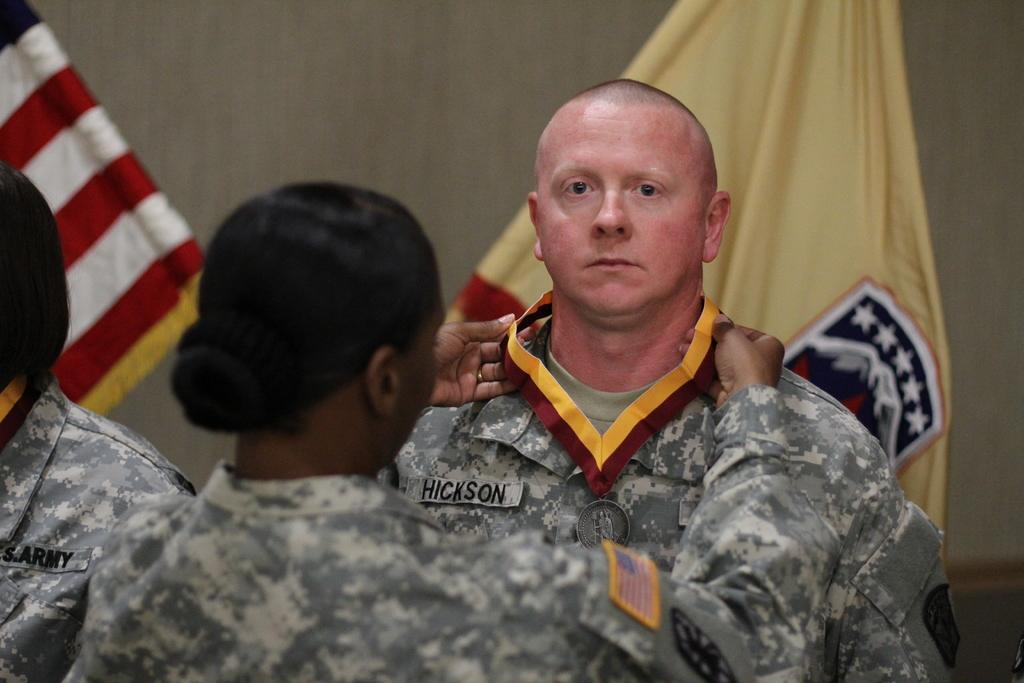What type of people can be seen in the image? There are army personnel in the image. Can you describe the interaction between the woman and the man? The woman is touching the medal of a man, who is standing in front of her. What can be seen in the background of the image? There are flags and a wall in the background of the image. What type of crime is being committed in the image? There is no crime being committed in the image; it features army personnel and a woman interacting with a man. Can you describe the kick performed by the woman in the image? There is no kick performed by the woman in the image; she is touching the medal of a man. 